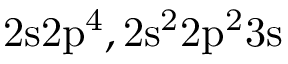Convert formula to latex. <formula><loc_0><loc_0><loc_500><loc_500>2 s 2 p ^ { 4 } , 2 s ^ { 2 } 2 p ^ { 2 } 3 s</formula> 